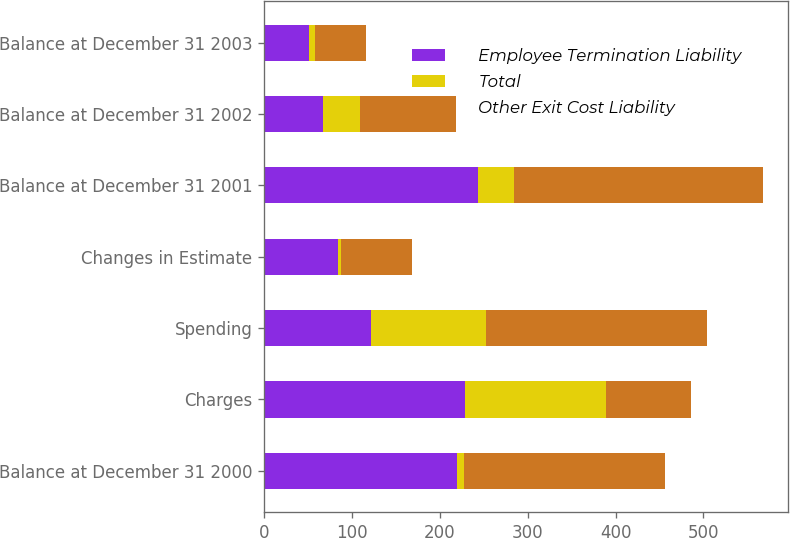Convert chart. <chart><loc_0><loc_0><loc_500><loc_500><stacked_bar_chart><ecel><fcel>Balance at December 31 2000<fcel>Charges<fcel>Spending<fcel>Changes in Estimate<fcel>Balance at December 31 2001<fcel>Balance at December 31 2002<fcel>Balance at December 31 2003<nl><fcel>Employee Termination Liability<fcel>220<fcel>229<fcel>122<fcel>84<fcel>243<fcel>67<fcel>51<nl><fcel>Total<fcel>8<fcel>160<fcel>130<fcel>3<fcel>41<fcel>42<fcel>7<nl><fcel>Other Exit Cost Liability<fcel>228<fcel>96.5<fcel>252<fcel>81<fcel>284<fcel>109<fcel>58<nl></chart> 